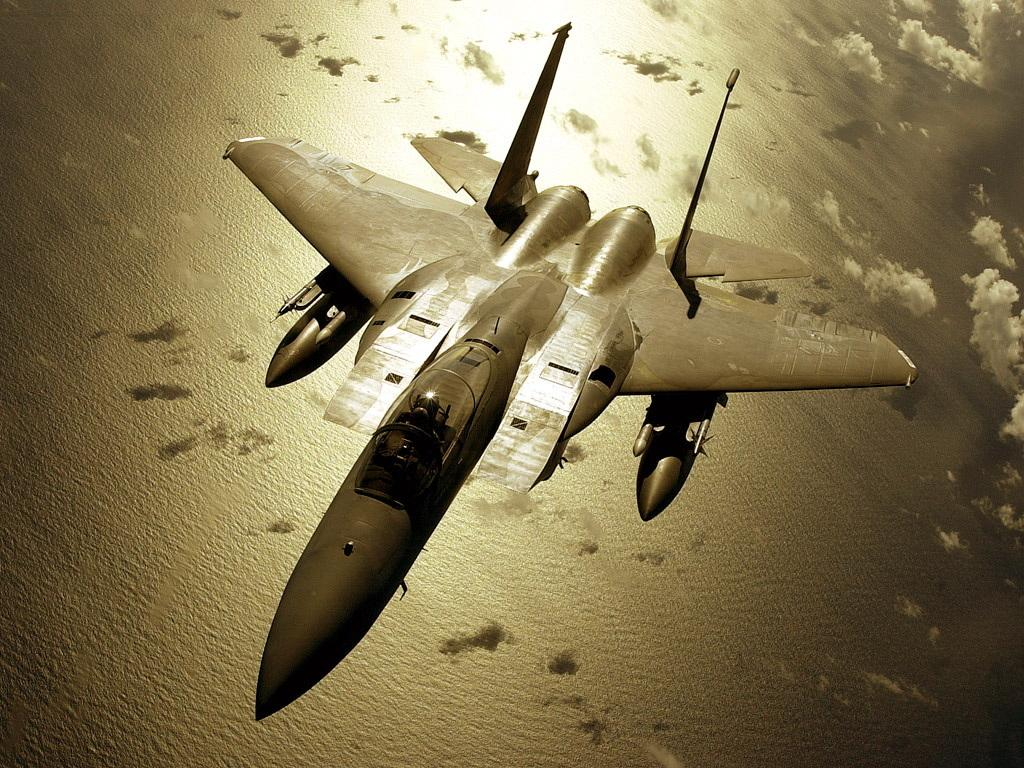What is the main subject of the image? The main subject of the image is an aircraft. Where is the aircraft located in the image? The aircraft is in the sky. What type of eggs can be seen hanging from the aircraft in the image? There are no eggs present in the image, and therefore no such activity can be observed. 